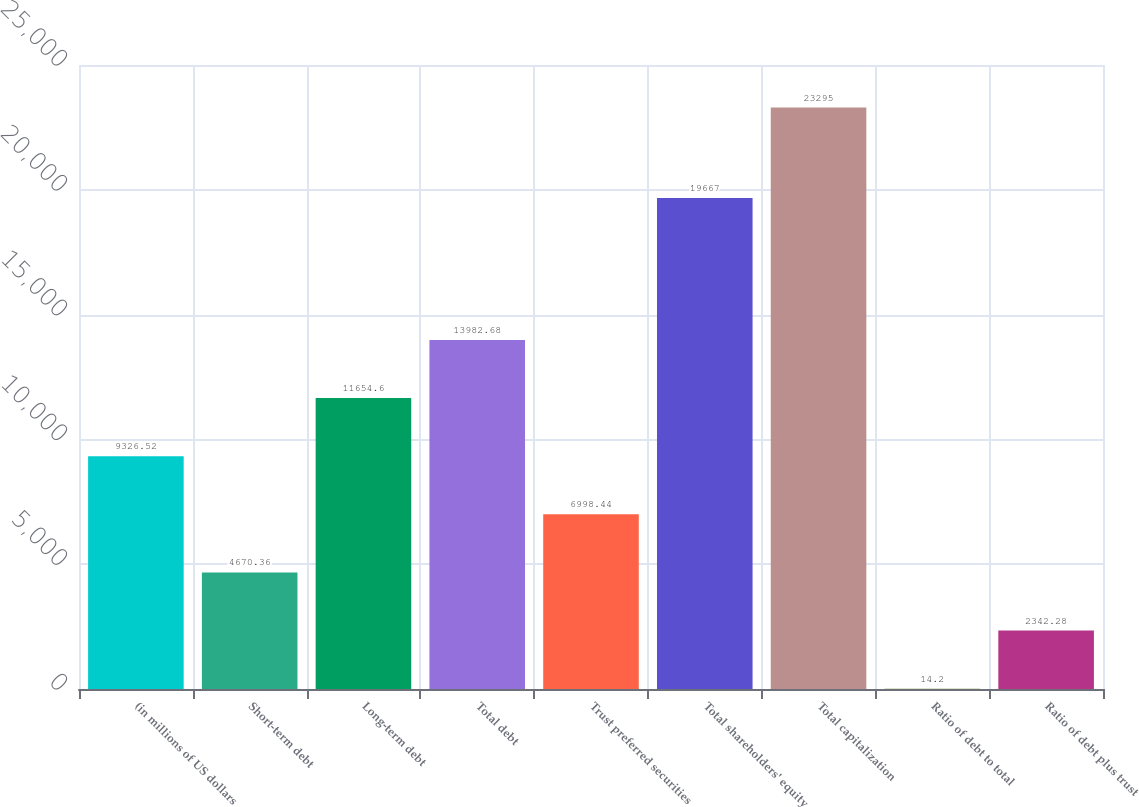<chart> <loc_0><loc_0><loc_500><loc_500><bar_chart><fcel>(in millions of US dollars<fcel>Short-term debt<fcel>Long-term debt<fcel>Total debt<fcel>Trust preferred securities<fcel>Total shareholders' equity<fcel>Total capitalization<fcel>Ratio of debt to total<fcel>Ratio of debt plus trust<nl><fcel>9326.52<fcel>4670.36<fcel>11654.6<fcel>13982.7<fcel>6998.44<fcel>19667<fcel>23295<fcel>14.2<fcel>2342.28<nl></chart> 